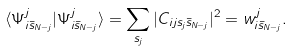<formula> <loc_0><loc_0><loc_500><loc_500>\langle \Psi ^ { j } _ { i \bar { s } _ { N - j } } | \Psi ^ { j } _ { i \bar { s } _ { N - j } } \rangle = \sum _ { s _ { j } } | C _ { i j s _ { j } \bar { s } _ { N - j } } | ^ { 2 } = w ^ { j } _ { i \bar { s } _ { N - j } } .</formula> 